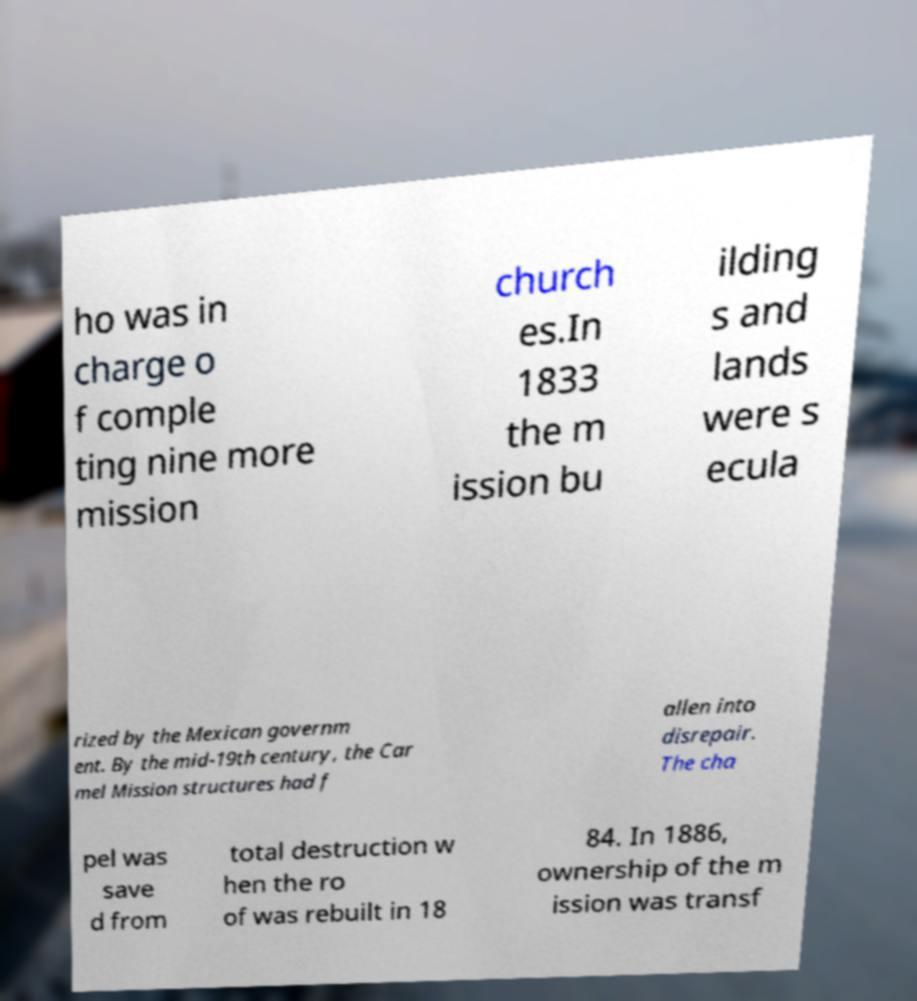I need the written content from this picture converted into text. Can you do that? ho was in charge o f comple ting nine more mission church es.In 1833 the m ission bu ilding s and lands were s ecula rized by the Mexican governm ent. By the mid-19th century, the Car mel Mission structures had f allen into disrepair. The cha pel was save d from total destruction w hen the ro of was rebuilt in 18 84. In 1886, ownership of the m ission was transf 